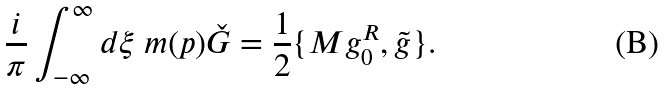Convert formula to latex. <formula><loc_0><loc_0><loc_500><loc_500>\frac { i } { \pi } \int _ { - \infty } ^ { \infty } d \xi \ m ( p ) \check { G } = \frac { 1 } { 2 } \{ M g _ { 0 } ^ { R } , \tilde { g } \} .</formula> 